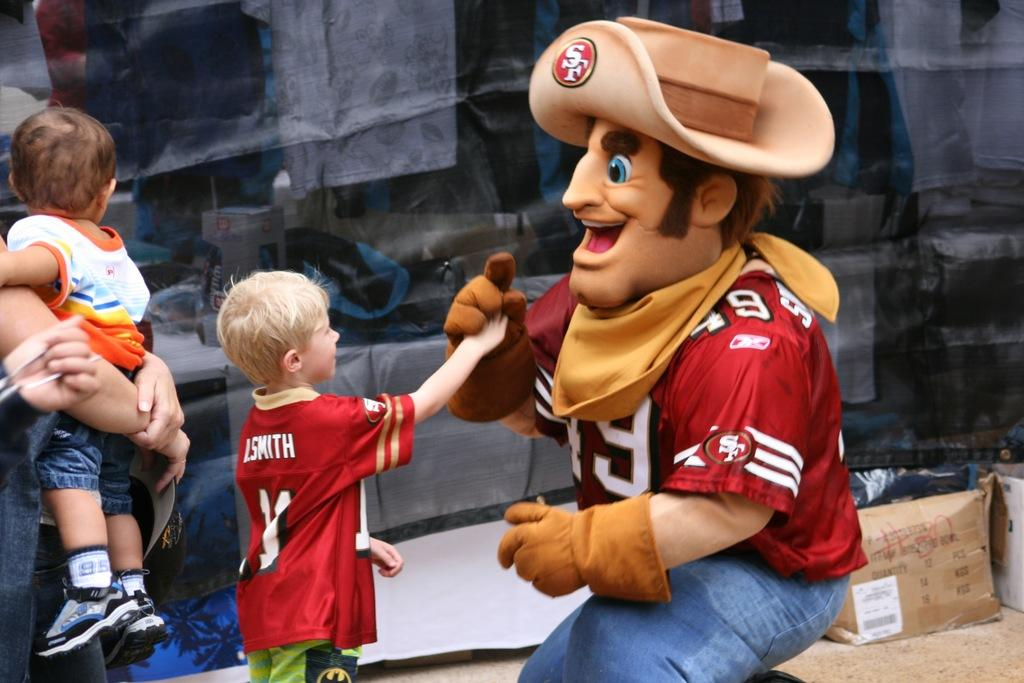<image>
Share a concise interpretation of the image provided. A man dressed as a cowboy mascot is shaking hands with a kid whose jersey says Smith. 